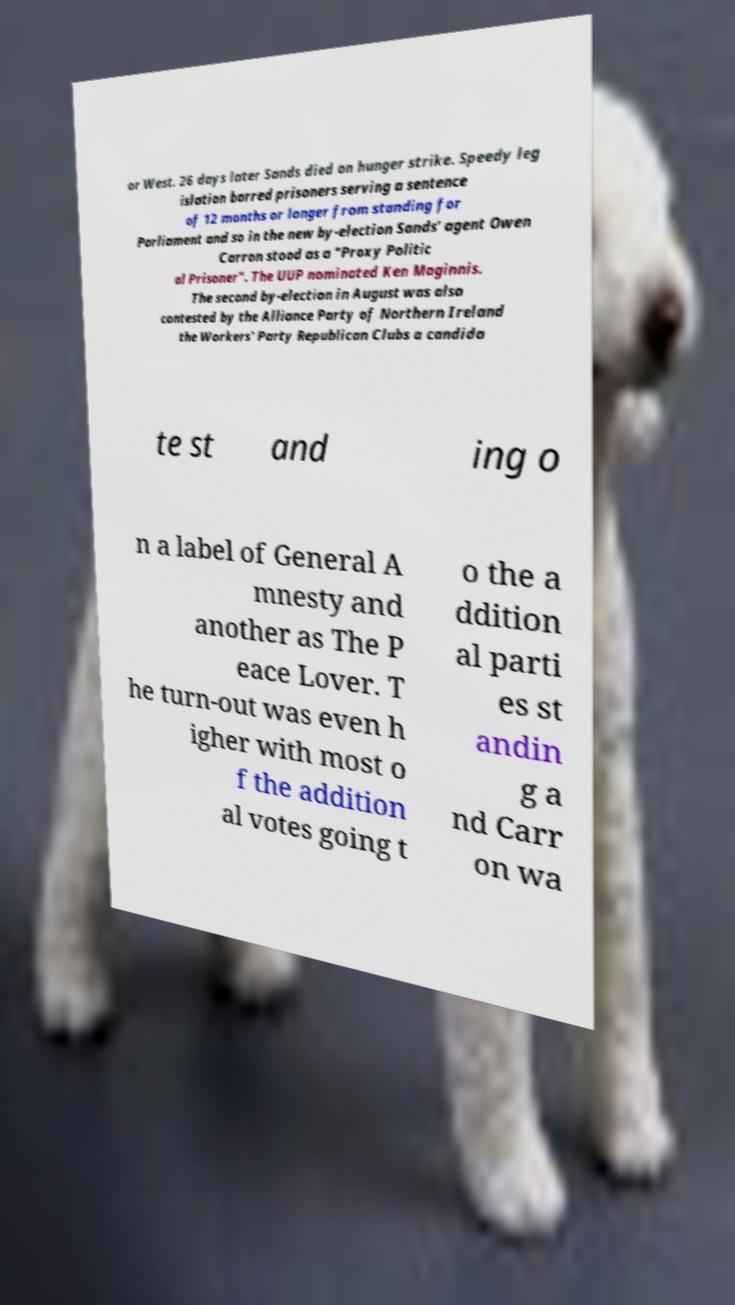Could you assist in decoding the text presented in this image and type it out clearly? or West. 26 days later Sands died on hunger strike. Speedy leg islation barred prisoners serving a sentence of 12 months or longer from standing for Parliament and so in the new by-election Sands' agent Owen Carron stood as a "Proxy Politic al Prisoner". The UUP nominated Ken Maginnis. The second by-election in August was also contested by the Alliance Party of Northern Ireland the Workers' Party Republican Clubs a candida te st and ing o n a label of General A mnesty and another as The P eace Lover. T he turn-out was even h igher with most o f the addition al votes going t o the a ddition al parti es st andin g a nd Carr on wa 